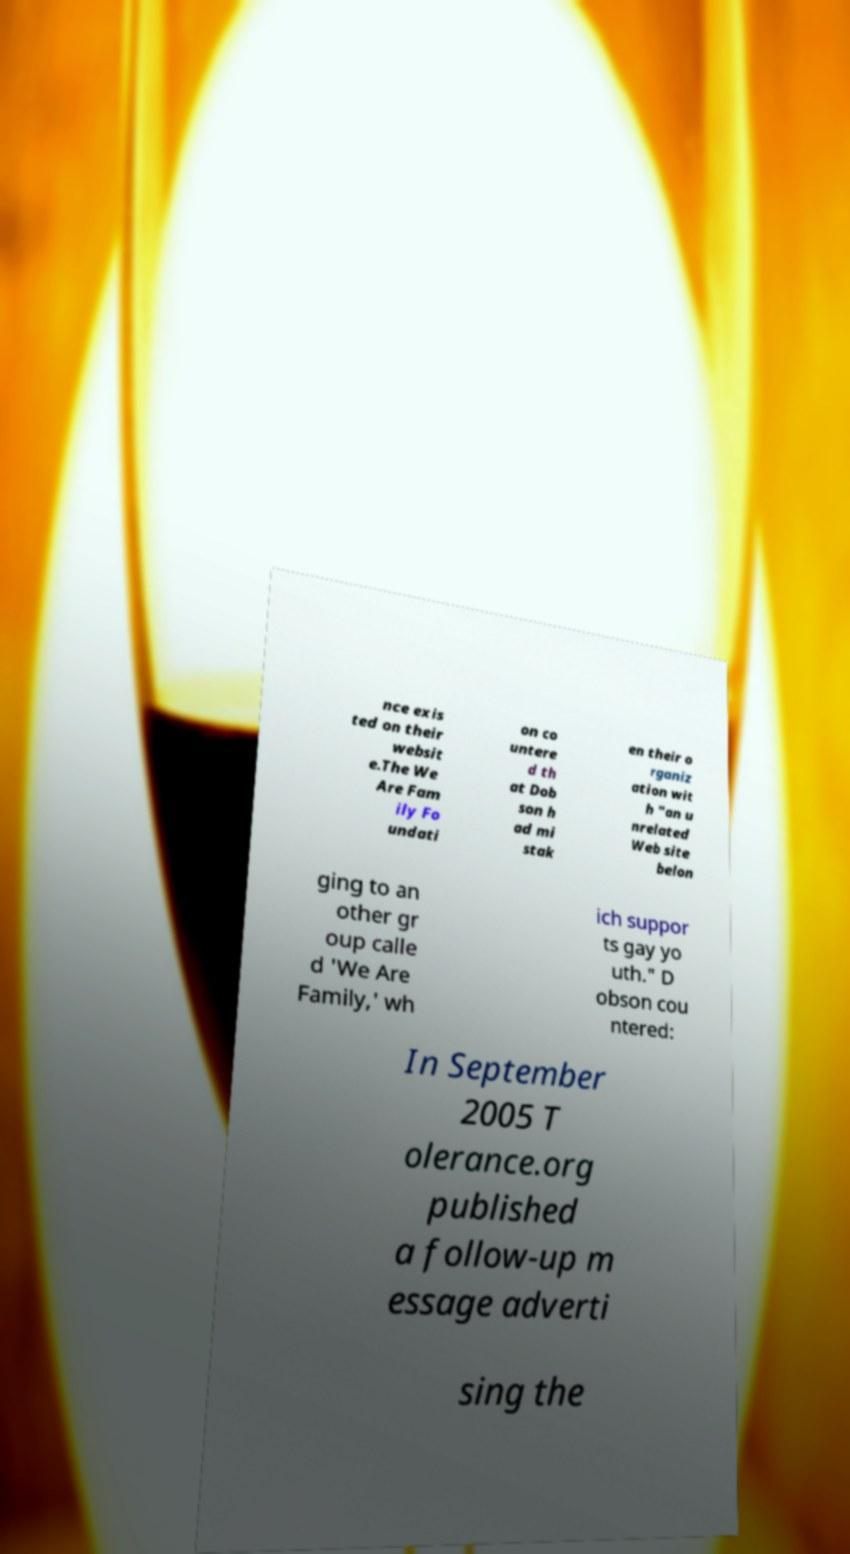For documentation purposes, I need the text within this image transcribed. Could you provide that? nce exis ted on their websit e.The We Are Fam ily Fo undati on co untere d th at Dob son h ad mi stak en their o rganiz ation wit h "an u nrelated Web site belon ging to an other gr oup calle d 'We Are Family,' wh ich suppor ts gay yo uth." D obson cou ntered: In September 2005 T olerance.org published a follow-up m essage adverti sing the 